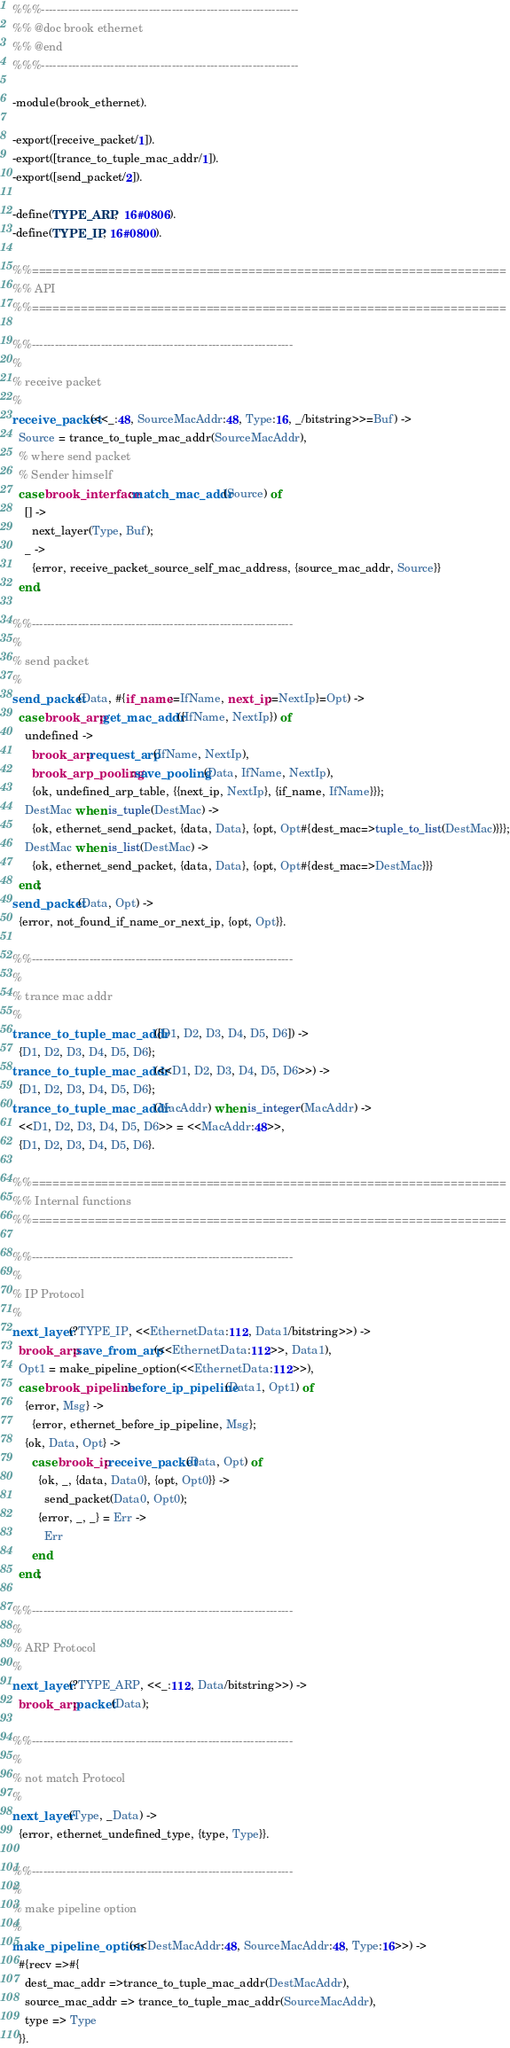Convert code to text. <code><loc_0><loc_0><loc_500><loc_500><_Erlang_>%%%-------------------------------------------------------------------
%% @doc brook ethernet
%% @end
%%%-------------------------------------------------------------------

-module(brook_ethernet).

-export([receive_packet/1]).
-export([trance_to_tuple_mac_addr/1]).
-export([send_packet/2]).

-define(TYPE_ARP,  16#0806).
-define(TYPE_IP, 16#0800).

%%====================================================================
%% API
%%====================================================================

%%--------------------------------------------------------------------
%
% receive packet
%
receive_packet(<<_:48, SourceMacAddr:48, Type:16, _/bitstring>>=Buf) ->
  Source = trance_to_tuple_mac_addr(SourceMacAddr),
  % where send packet
  % Sender himself
  case brook_interface:match_mac_addr(Source) of
    [] ->
      next_layer(Type, Buf);
    _ ->
      {error, receive_packet_source_self_mac_address, {source_mac_addr, Source}}
  end.

%%--------------------------------------------------------------------
%
% send packet
%
send_packet(Data, #{if_name:=IfName, next_ip:=NextIp}=Opt) ->
  case brook_arp:get_mac_addr({IfName, NextIp}) of
    undefined ->
      brook_arp:request_arp(IfName, NextIp),
      brook_arp_pooling:save_pooling(Data, IfName, NextIp),
      {ok, undefined_arp_table, {{next_ip, NextIp}, {if_name, IfName}}};
    DestMac when is_tuple(DestMac) ->
      {ok, ethernet_send_packet, {data, Data}, {opt, Opt#{dest_mac=>tuple_to_list(DestMac)}}};
    DestMac when is_list(DestMac) ->
      {ok, ethernet_send_packet, {data, Data}, {opt, Opt#{dest_mac=>DestMac}}}
  end;
send_packet(Data, Opt) ->
  {error, not_found_if_name_or_next_ip, {opt, Opt}}.

%%--------------------------------------------------------------------
%
% trance mac addr
%
trance_to_tuple_mac_addr([D1, D2, D3, D4, D5, D6]) ->
  {D1, D2, D3, D4, D5, D6};
trance_to_tuple_mac_addr(<<D1, D2, D3, D4, D5, D6>>) ->
  {D1, D2, D3, D4, D5, D6};
trance_to_tuple_mac_addr(MacAddr) when is_integer(MacAddr) ->
  <<D1, D2, D3, D4, D5, D6>> = <<MacAddr:48>>,
  {D1, D2, D3, D4, D5, D6}.

%%====================================================================
%% Internal functions
%%====================================================================

%%--------------------------------------------------------------------
%
% IP Protocol
%
next_layer(?TYPE_IP, <<EthernetData:112, Data1/bitstring>>) ->
  brook_arp:save_from_arp(<<EthernetData:112>>, Data1),
  Opt1 = make_pipeline_option(<<EthernetData:112>>),
  case brook_pipeline:before_ip_pipeline(Data1, Opt1) of
    {error, Msg} ->
      {error, ethernet_before_ip_pipeline, Msg};
    {ok, Data, Opt} ->
      case brook_ip:receive_packet(Data, Opt) of
        {ok, _, {data, Data0}, {opt, Opt0}} ->
          send_packet(Data0, Opt0);
        {error, _, _} = Err ->
          Err
      end
  end;

%%--------------------------------------------------------------------
%
% ARP Protocol
%
next_layer(?TYPE_ARP, <<_:112, Data/bitstring>>) ->
  brook_arp:packet(Data);

%%--------------------------------------------------------------------
%
% not match Protocol
%
next_layer(Type, _Data) ->
  {error, ethernet_undefined_type, {type, Type}}.

%%--------------------------------------------------------------------
%
% make pipeline option
%
make_pipeline_option(<<DestMacAddr:48, SourceMacAddr:48, Type:16>>) ->
  #{recv =>#{
    dest_mac_addr =>trance_to_tuple_mac_addr(DestMacAddr),
    source_mac_addr => trance_to_tuple_mac_addr(SourceMacAddr),
    type => Type
  }}.

</code> 